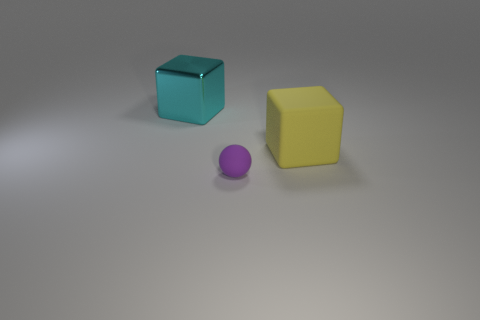Is the big yellow thing the same shape as the small matte thing? The large yellow object appears to be a cube and has a smooth surface that reflects light, highlighting its geometric shape. In contrast, the small matte object, which is a sphere, has a surface that does not reflect light, giving it a flatter color profile. Therefore, no, they are not the same shape; one is a cube and the other is a sphere. 